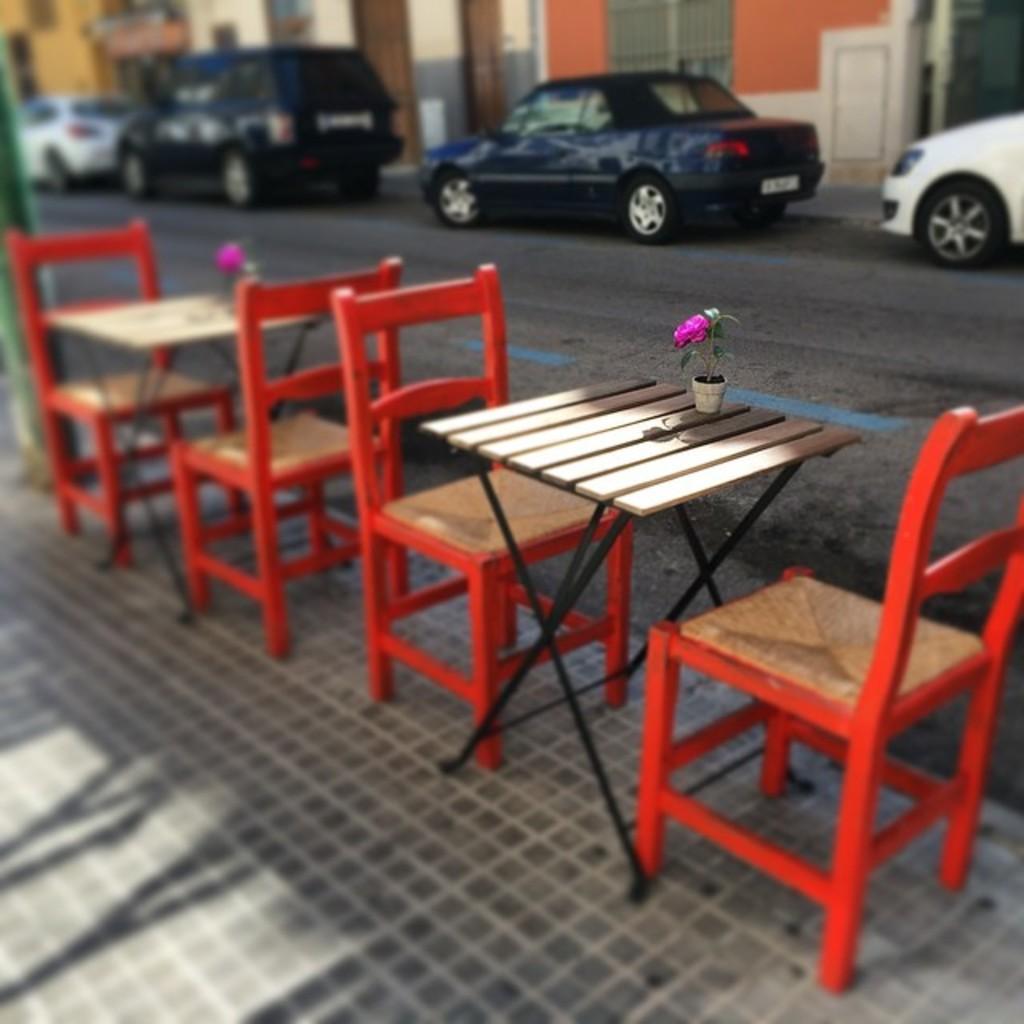Can you describe this image briefly? It is an outdoor picture where there are empty chairs and tables are present on the road, the chairs are in red colour and on the table there is a one small flower plant and beside them there is a road and there are vehicles on the road and beside the vehicle there is a one building in orange colour. 